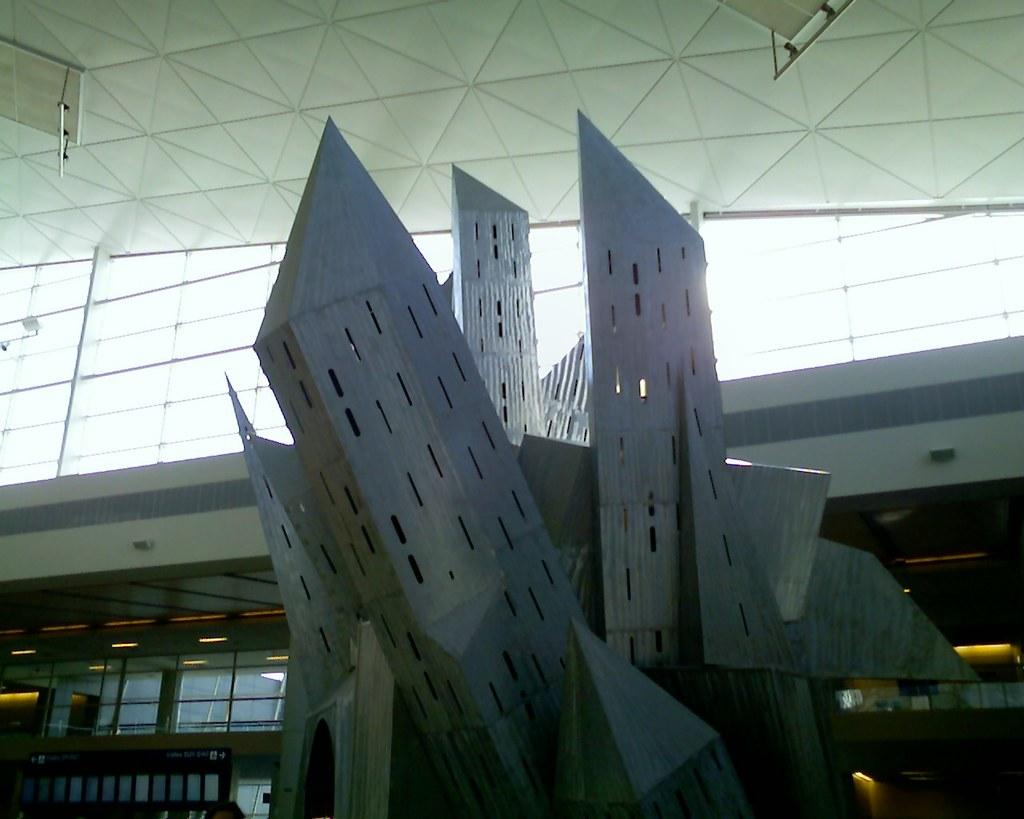What is the color of the object in the image? The object in the image is silver and white in color. What type of wall can be seen in the image? There is a glass wall in the image. What can be seen illuminating the scene in the image? There are lights visible in the image. Can you describe any other objects present in the image? There are other objects present in the image, but their specific details are not mentioned in the provided facts. What type of needle is being used by the lawyer in the image? There is no needle or lawyer present in the image; it only features an object in silver and white color, a glass wall, and lights. 